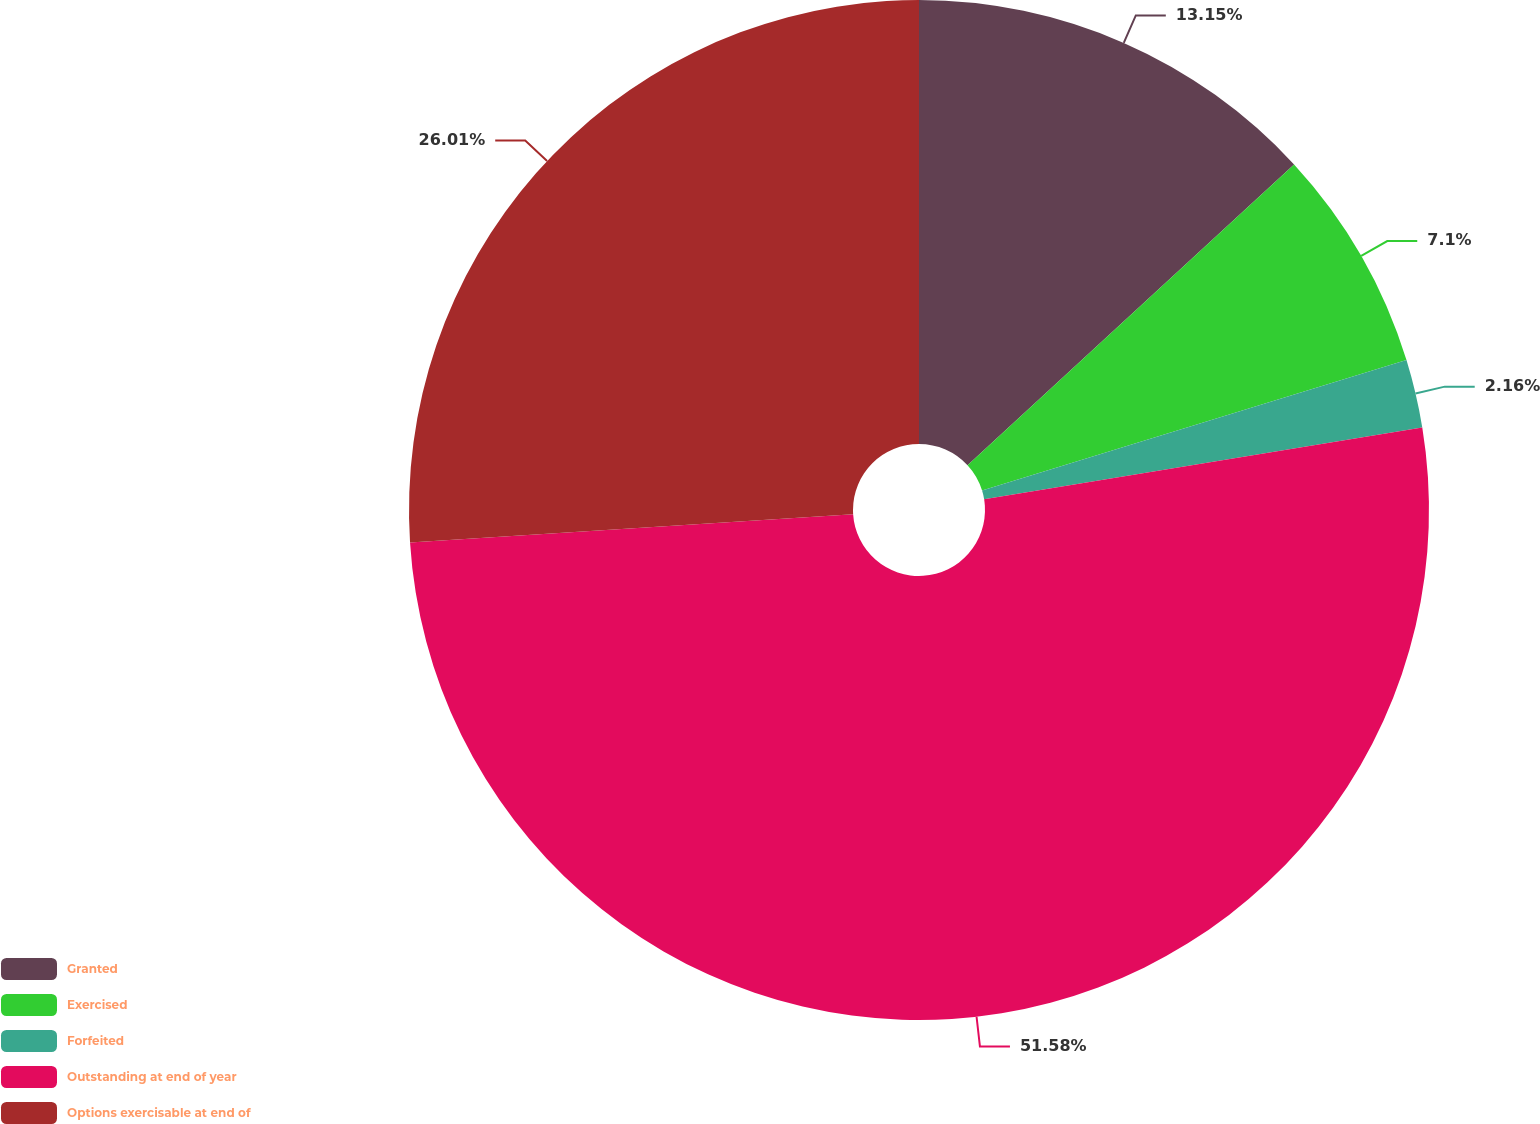Convert chart to OTSL. <chart><loc_0><loc_0><loc_500><loc_500><pie_chart><fcel>Granted<fcel>Exercised<fcel>Forfeited<fcel>Outstanding at end of year<fcel>Options exercisable at end of<nl><fcel>13.15%<fcel>7.1%<fcel>2.16%<fcel>51.57%<fcel>26.01%<nl></chart> 